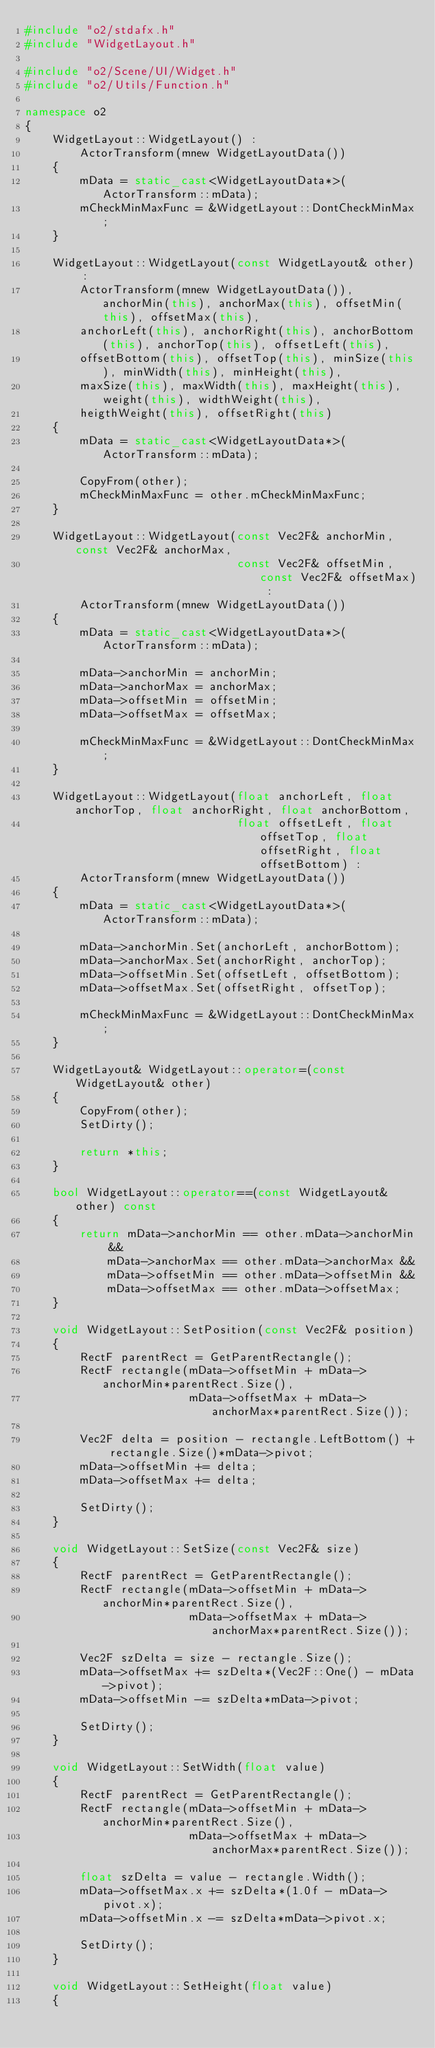<code> <loc_0><loc_0><loc_500><loc_500><_C++_>#include "o2/stdafx.h"
#include "WidgetLayout.h"

#include "o2/Scene/UI/Widget.h"
#include "o2/Utils/Function.h"

namespace o2
{
	WidgetLayout::WidgetLayout() :
		ActorTransform(mnew WidgetLayoutData())
	{
		mData = static_cast<WidgetLayoutData*>(ActorTransform::mData);
		mCheckMinMaxFunc = &WidgetLayout::DontCheckMinMax;
	}

	WidgetLayout::WidgetLayout(const WidgetLayout& other) :
		ActorTransform(mnew WidgetLayoutData()), anchorMin(this), anchorMax(this), offsetMin(this), offsetMax(this),
		anchorLeft(this), anchorRight(this), anchorBottom(this), anchorTop(this), offsetLeft(this),
		offsetBottom(this), offsetTop(this), minSize(this), minWidth(this), minHeight(this),
		maxSize(this), maxWidth(this), maxHeight(this), weight(this), widthWeight(this),
		heigthWeight(this), offsetRight(this)
	{
		mData = static_cast<WidgetLayoutData*>(ActorTransform::mData);

		CopyFrom(other);
		mCheckMinMaxFunc = other.mCheckMinMaxFunc;
	}

	WidgetLayout::WidgetLayout(const Vec2F& anchorMin, const Vec2F& anchorMax,
							   const Vec2F& offsetMin, const Vec2F& offsetMax) :
		ActorTransform(mnew WidgetLayoutData())
	{
		mData = static_cast<WidgetLayoutData*>(ActorTransform::mData);

		mData->anchorMin = anchorMin;
		mData->anchorMax = anchorMax;
		mData->offsetMin = offsetMin;
		mData->offsetMax = offsetMax;

		mCheckMinMaxFunc = &WidgetLayout::DontCheckMinMax;
	}

	WidgetLayout::WidgetLayout(float anchorLeft, float anchorTop, float anchorRight, float anchorBottom,
							   float offsetLeft, float offsetTop, float offsetRight, float offsetBottom) :
		ActorTransform(mnew WidgetLayoutData())
	{
		mData = static_cast<WidgetLayoutData*>(ActorTransform::mData);

		mData->anchorMin.Set(anchorLeft, anchorBottom);
		mData->anchorMax.Set(anchorRight, anchorTop);
		mData->offsetMin.Set(offsetLeft, offsetBottom);
		mData->offsetMax.Set(offsetRight, offsetTop);

		mCheckMinMaxFunc = &WidgetLayout::DontCheckMinMax;
	}

	WidgetLayout& WidgetLayout::operator=(const WidgetLayout& other)
	{
		CopyFrom(other);
		SetDirty();

		return *this;
	}

	bool WidgetLayout::operator==(const WidgetLayout& other) const
	{
		return mData->anchorMin == other.mData->anchorMin &&
			mData->anchorMax == other.mData->anchorMax &&
			mData->offsetMin == other.mData->offsetMin &&
			mData->offsetMax == other.mData->offsetMax;
	}

	void WidgetLayout::SetPosition(const Vec2F& position)
	{
		RectF parentRect = GetParentRectangle();
		RectF rectangle(mData->offsetMin + mData->anchorMin*parentRect.Size(),
						mData->offsetMax + mData->anchorMax*parentRect.Size());

		Vec2F delta = position - rectangle.LeftBottom() + rectangle.Size()*mData->pivot;
		mData->offsetMin += delta;
		mData->offsetMax += delta;

		SetDirty();
	}

	void WidgetLayout::SetSize(const Vec2F& size)
	{
		RectF parentRect = GetParentRectangle();
		RectF rectangle(mData->offsetMin + mData->anchorMin*parentRect.Size(),
						mData->offsetMax + mData->anchorMax*parentRect.Size());

		Vec2F szDelta = size - rectangle.Size();
		mData->offsetMax += szDelta*(Vec2F::One() - mData->pivot);
		mData->offsetMin -= szDelta*mData->pivot;

		SetDirty();
	}

	void WidgetLayout::SetWidth(float value)
	{
		RectF parentRect = GetParentRectangle();
		RectF rectangle(mData->offsetMin + mData->anchorMin*parentRect.Size(),
						mData->offsetMax + mData->anchorMax*parentRect.Size());

		float szDelta = value - rectangle.Width();
		mData->offsetMax.x += szDelta*(1.0f - mData->pivot.x);
		mData->offsetMin.x -= szDelta*mData->pivot.x;

		SetDirty();
	}

	void WidgetLayout::SetHeight(float value)
	{</code> 